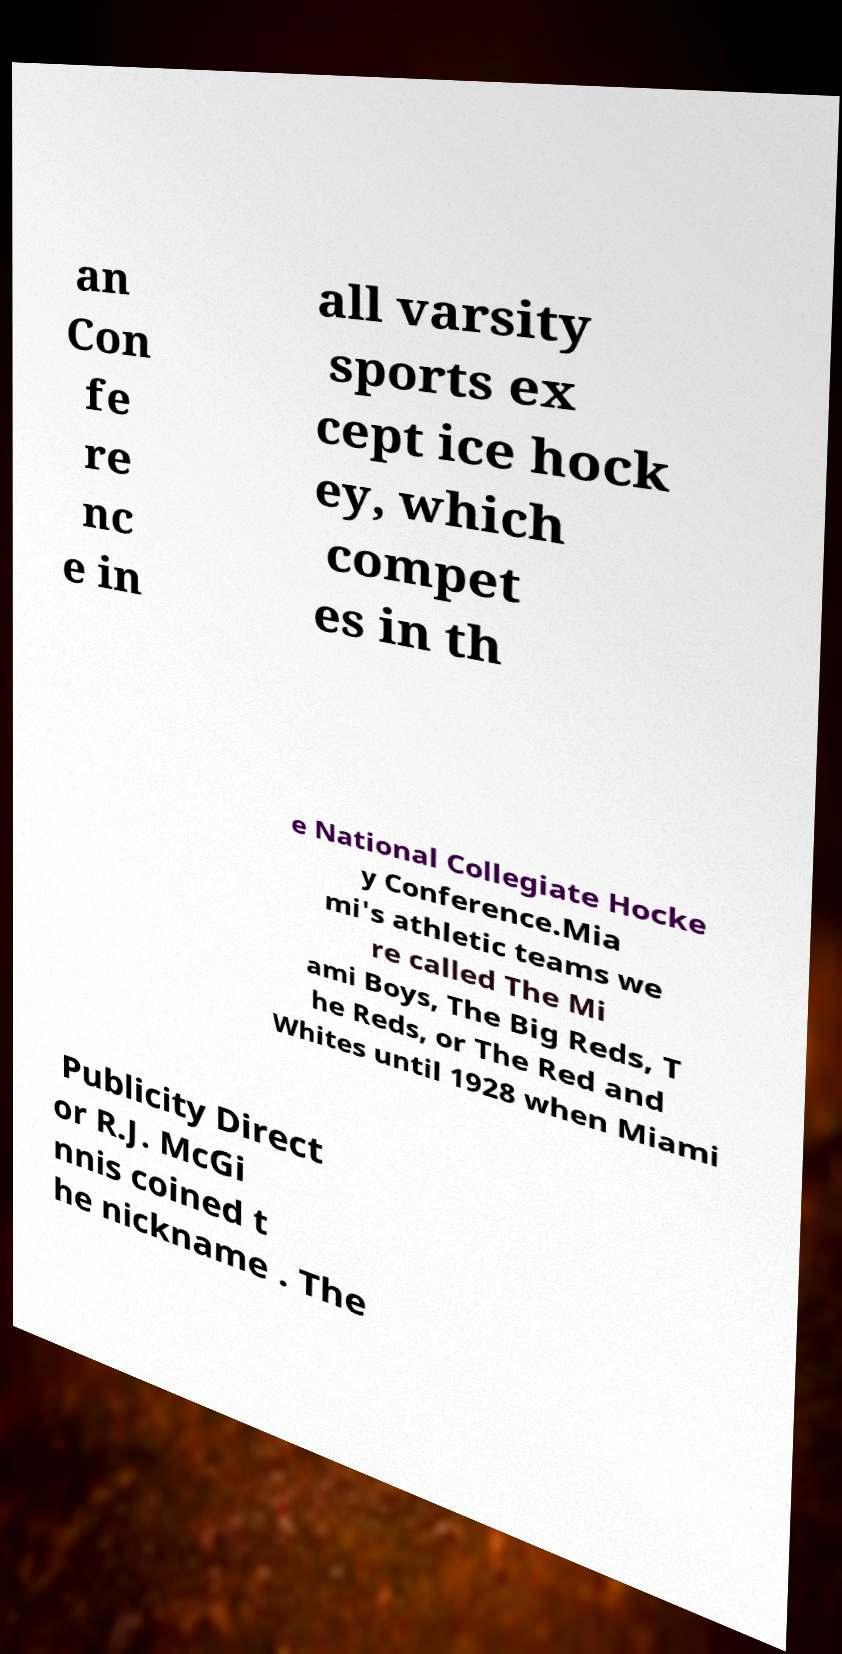Can you accurately transcribe the text from the provided image for me? an Con fe re nc e in all varsity sports ex cept ice hock ey, which compet es in th e National Collegiate Hocke y Conference.Mia mi's athletic teams we re called The Mi ami Boys, The Big Reds, T he Reds, or The Red and Whites until 1928 when Miami Publicity Direct or R.J. McGi nnis coined t he nickname . The 